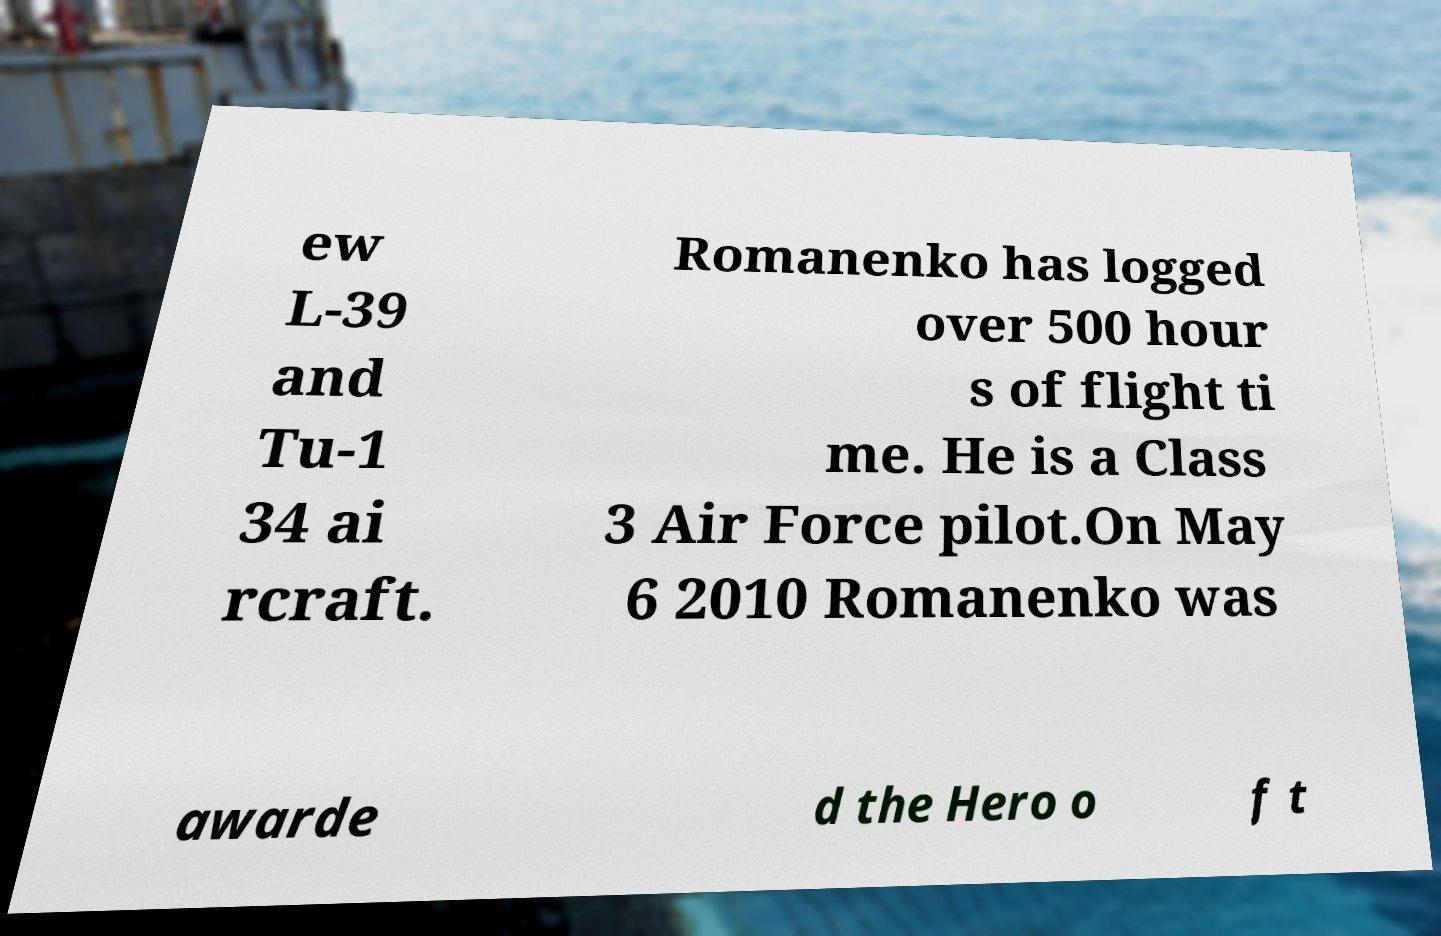Could you assist in decoding the text presented in this image and type it out clearly? ew L-39 and Tu-1 34 ai rcraft. Romanenko has logged over 500 hour s of flight ti me. He is a Class 3 Air Force pilot.On May 6 2010 Romanenko was awarde d the Hero o f t 